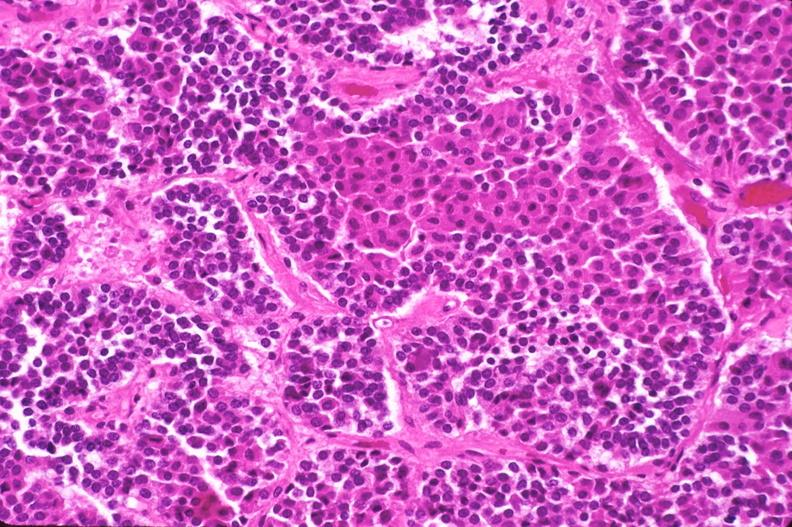does marfans syndrome show pituitary, chromaphobe adenoma?
Answer the question using a single word or phrase. No 